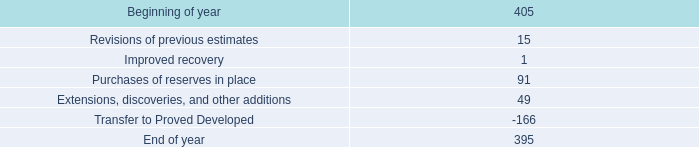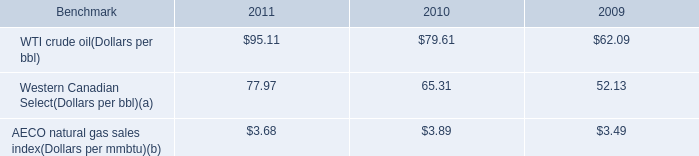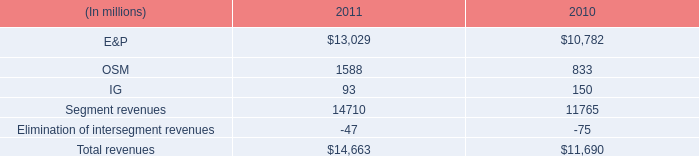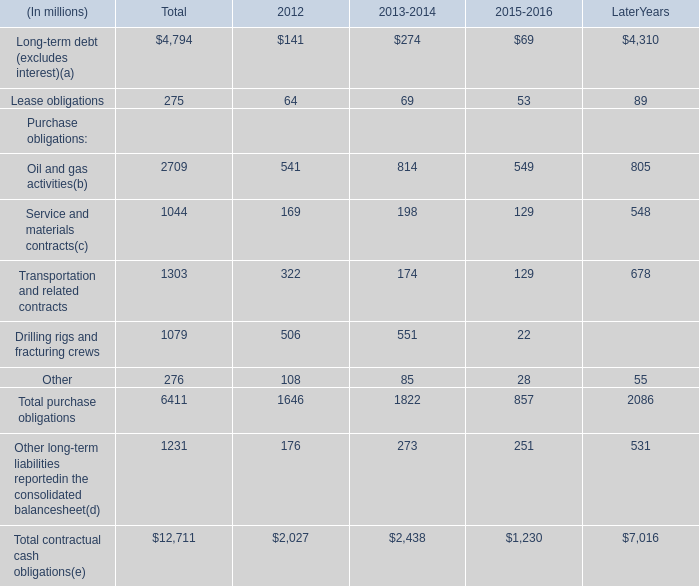What is the 80% of the value of the Total purchase obligations in 2012? (in million) 
Computations: (0.8 * 1646)
Answer: 1316.8. 